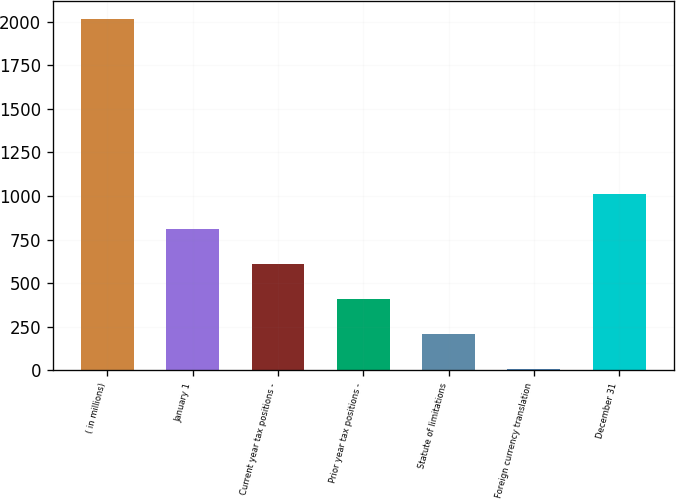Convert chart. <chart><loc_0><loc_0><loc_500><loc_500><bar_chart><fcel>( in millions)<fcel>January 1<fcel>Current year tax positions -<fcel>Prior year tax positions -<fcel>Statute of limitations<fcel>Foreign currency translation<fcel>December 31<nl><fcel>2018<fcel>810.2<fcel>608.9<fcel>407.6<fcel>206.3<fcel>5<fcel>1011.5<nl></chart> 